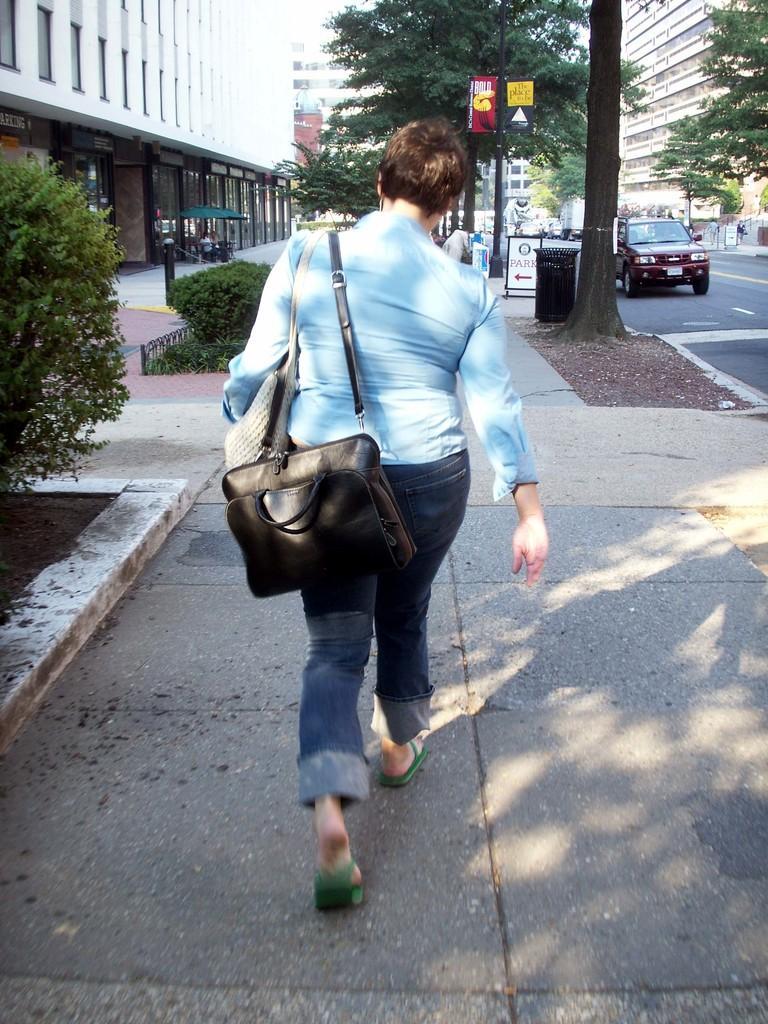Describe this image in one or two sentences. A woman is walking on footpath with a bag. 